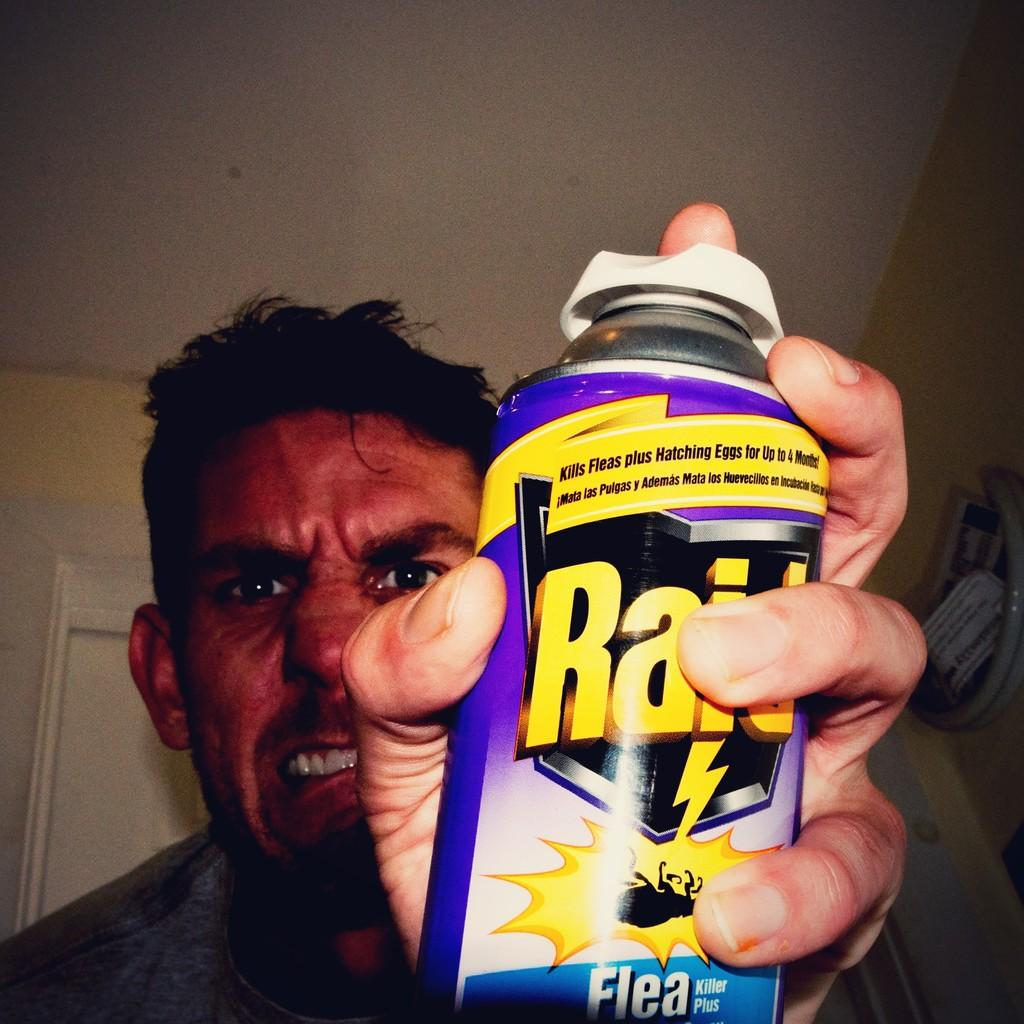What is the main subject of the image? There is a person in the image. What is the person holding in the image? The person is holding a tin. What can be seen behind the person in the image? There is a wall visible in the image. What is visible at the top of the image? The ceiling is visible at the top of the image. What type of disease is the person suffering from in the image? There is no indication of any disease in the image; it only shows a person holding a tin. 